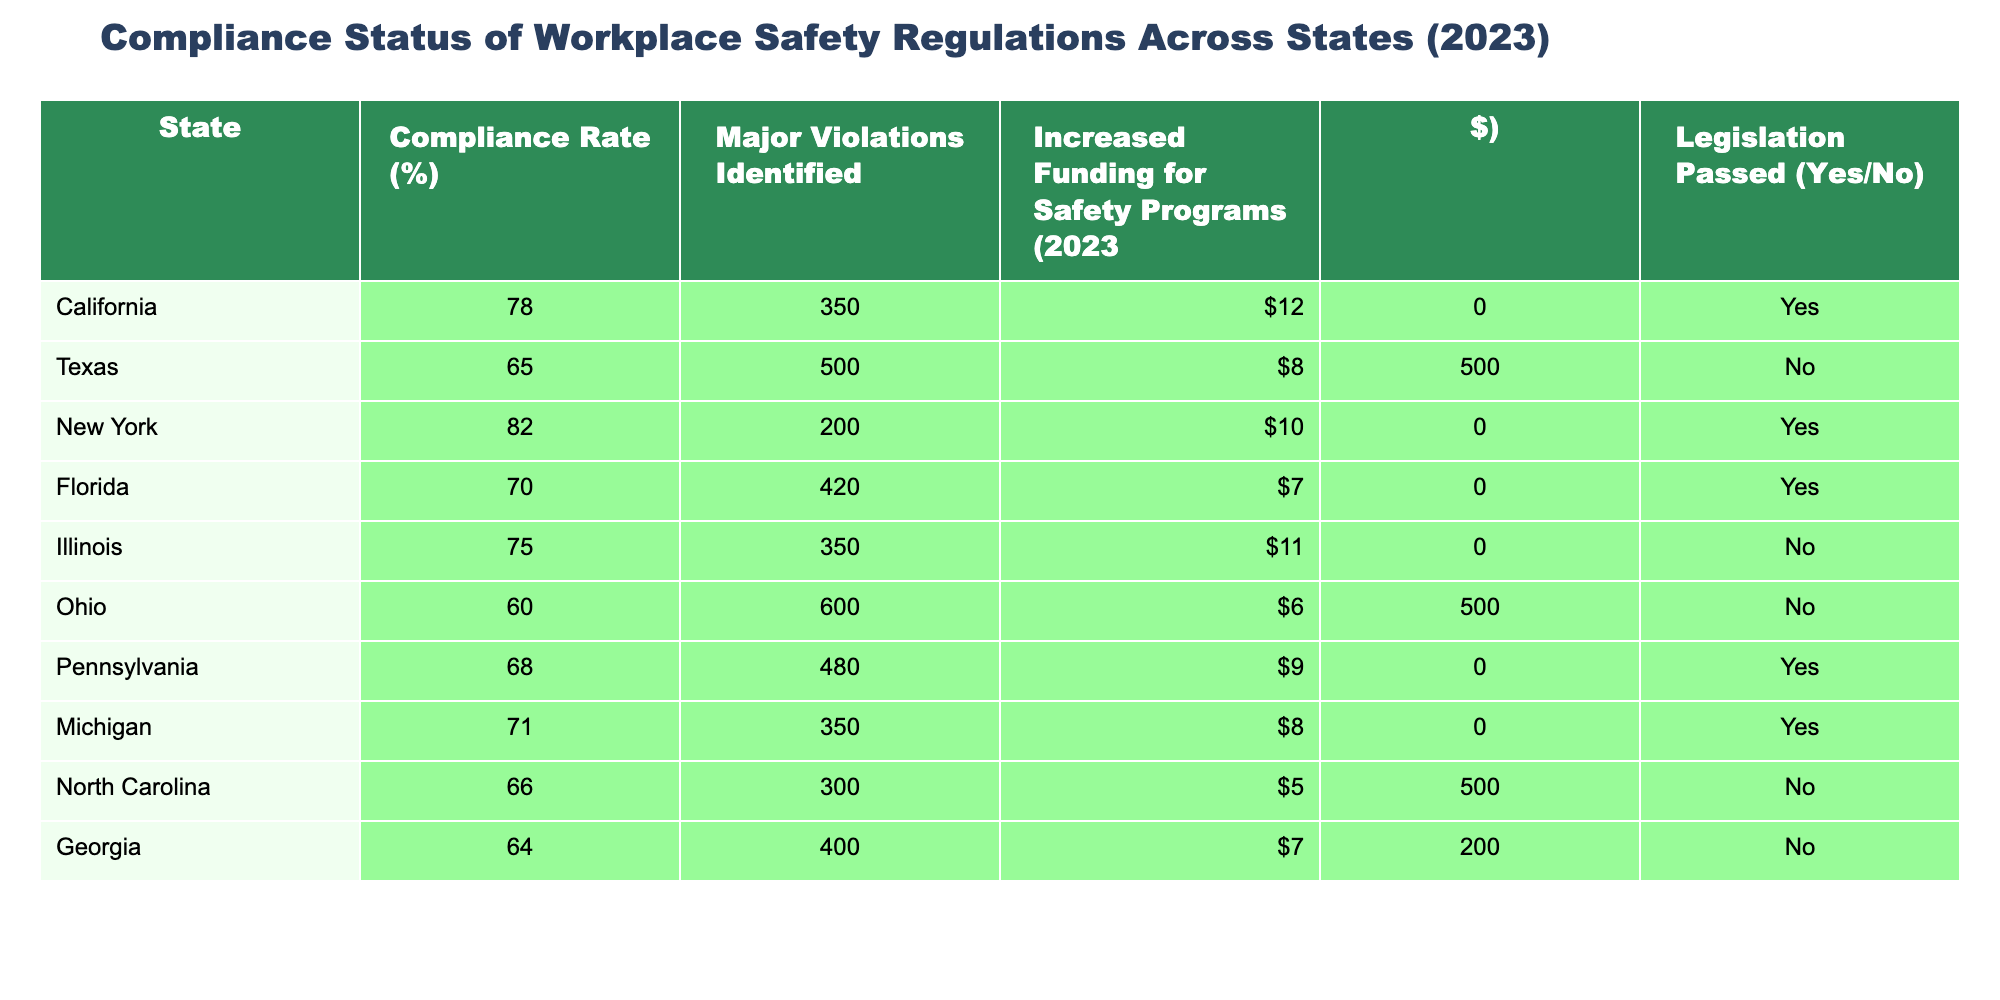What is the compliance rate for New York? From the table, the compliance rate for New York is directly listed under the "Compliance Rate (%)" column. It shows 82%.
Answer: 82% Which state has the highest number of major violations identified? By comparing the values in the "Major Violations Identified" column, Ohio has 600 major violations, which is the highest among all states listed.
Answer: Ohio What is the average compliance rate of the states that passed legislation? The states that passed legislation are California, New York, Florida, Pennsylvania, and Michigan. Their compliance rates are 78, 82, 70, 68, and 71 respectively. Adding these gives 78 + 82 + 70 + 68 + 71 = 369. There are 5 states, so the average is 369/5 = 73.8.
Answer: 73.8 Is there a correlation between increased funding for safety programs and compliance rate? To analyze this, we would look at both columns. For example, California has a compliance rate of 78% with $12,000 funding, but Texas has a lower compliance rate of 65% with $8,500 funding. Similarly, high funding does not consistently result in higher compliance rates. Therefore, no clear correlation can be established based on this table alone.
Answer: No clear correlation Which state has a compliance rate below 70% and did not pass legislation? By scanning the table, Ohio (60% compliance, No legislation) and Texas (65% compliance, No legislation) both meet this criterion.
Answer: Ohio and Texas 